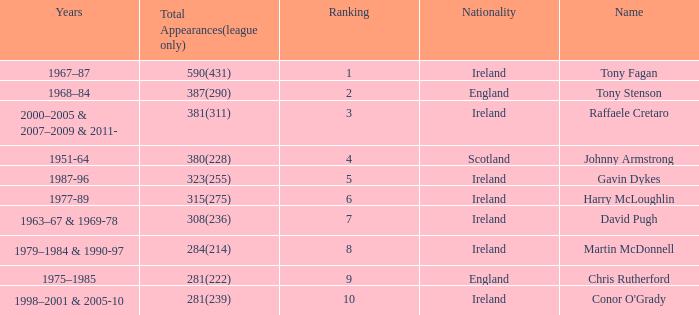What nationality has a ranking less than 7 with tony stenson as the name? England. 